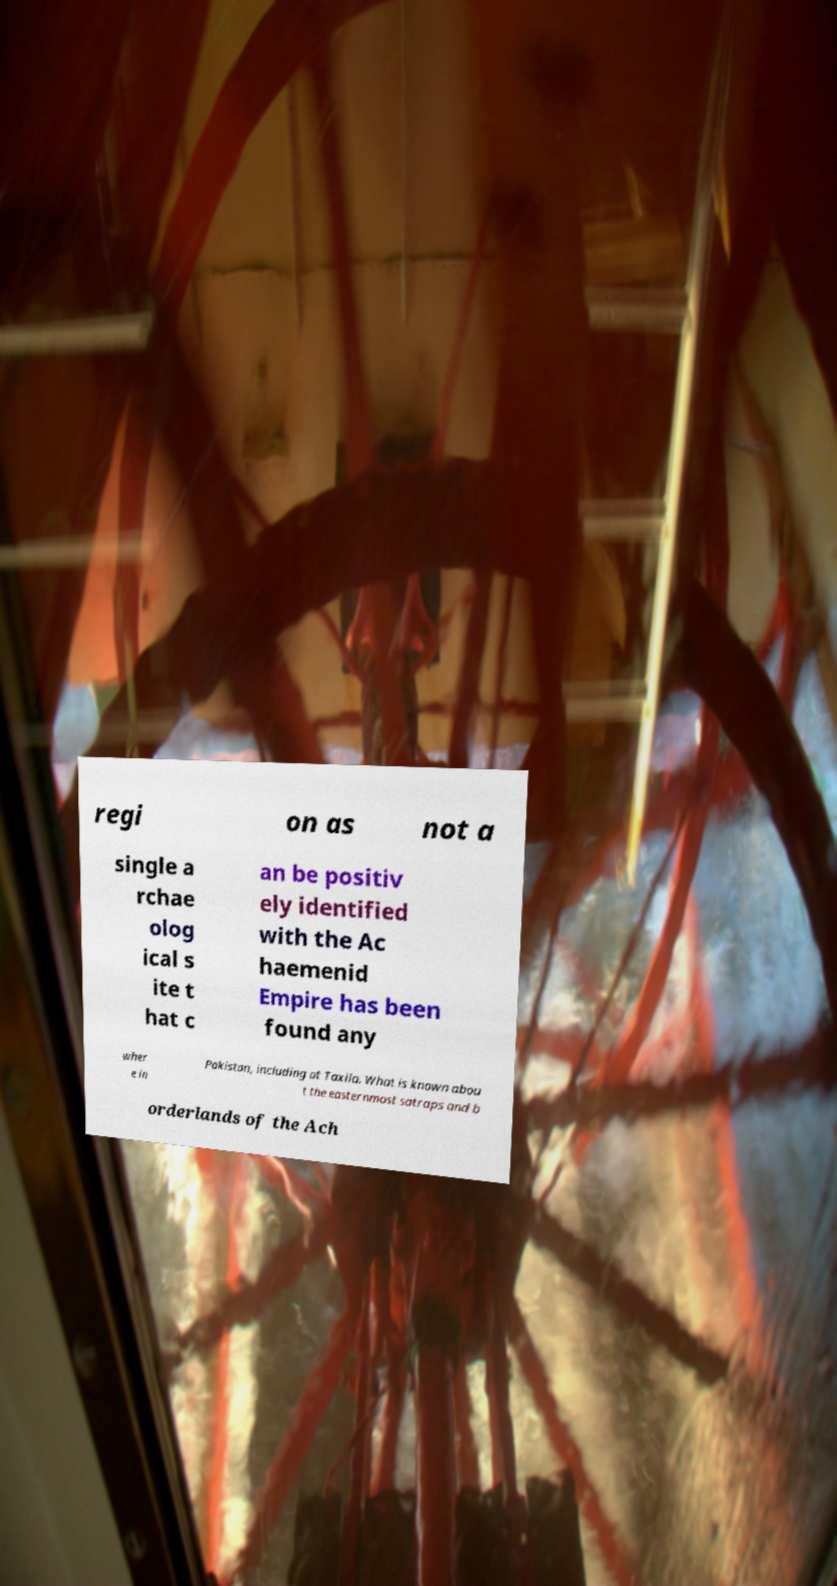Please read and relay the text visible in this image. What does it say? regi on as not a single a rchae olog ical s ite t hat c an be positiv ely identified with the Ac haemenid Empire has been found any wher e in Pakistan, including at Taxila. What is known abou t the easternmost satraps and b orderlands of the Ach 